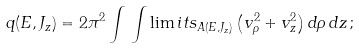Convert formula to latex. <formula><loc_0><loc_0><loc_500><loc_500>q ( E , J _ { z } ) = 2 \pi ^ { 2 } \int \, \int \lim i t s _ { A ( E , J _ { z } ) } \left ( v _ { \rho } ^ { 2 } + v _ { z } ^ { 2 } \right ) d \rho \, d z \, ;</formula> 